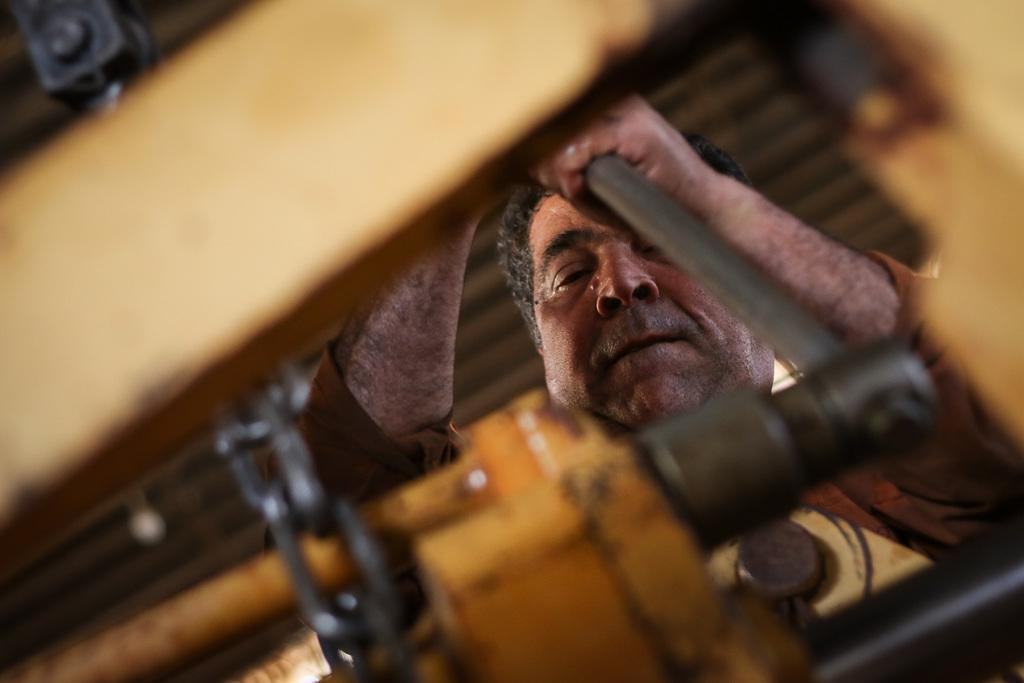What can be seen in the image? There is a person in the image. What is the person holding? The person is holding an object. Can you describe the objects made of metal in the image? There are metallic objects in the image. Is the person wearing a crown in the image? There is no crown visible in the image. Is there an umbrella present in the image? There is no umbrella present in the image. 